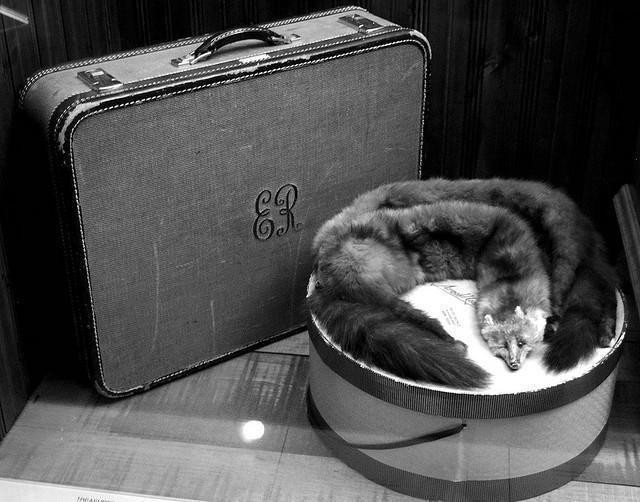How many black dogs are in the image?
Give a very brief answer. 0. 